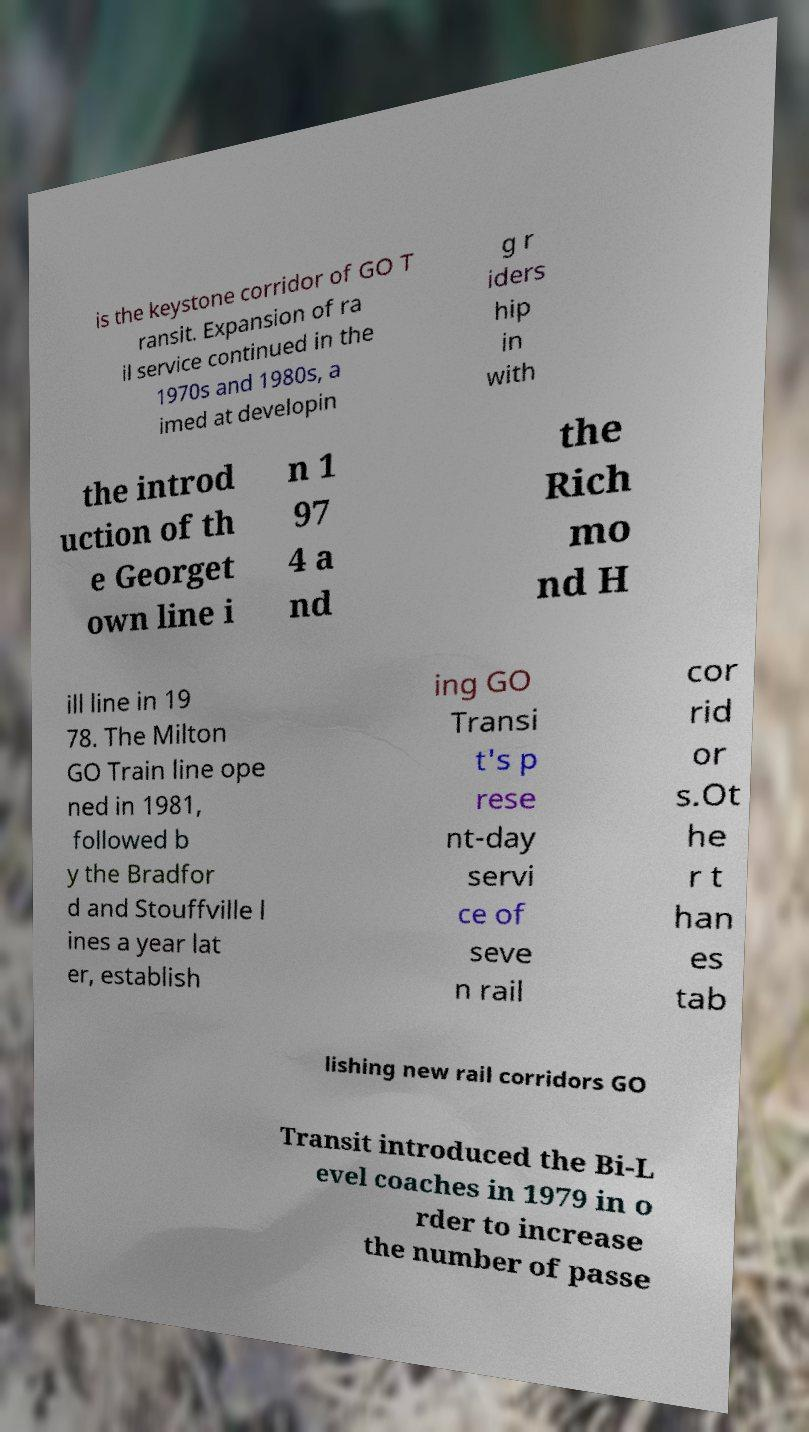Please read and relay the text visible in this image. What does it say? is the keystone corridor of GO T ransit. Expansion of ra il service continued in the 1970s and 1980s, a imed at developin g r iders hip in with the introd uction of th e Georget own line i n 1 97 4 a nd the Rich mo nd H ill line in 19 78. The Milton GO Train line ope ned in 1981, followed b y the Bradfor d and Stouffville l ines a year lat er, establish ing GO Transi t's p rese nt-day servi ce of seve n rail cor rid or s.Ot he r t han es tab lishing new rail corridors GO Transit introduced the Bi-L evel coaches in 1979 in o rder to increase the number of passe 